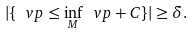Convert formula to latex. <formula><loc_0><loc_0><loc_500><loc_500>| \{ \ v p \leq \inf _ { M } \ v p + C \} | \geq \delta .</formula> 